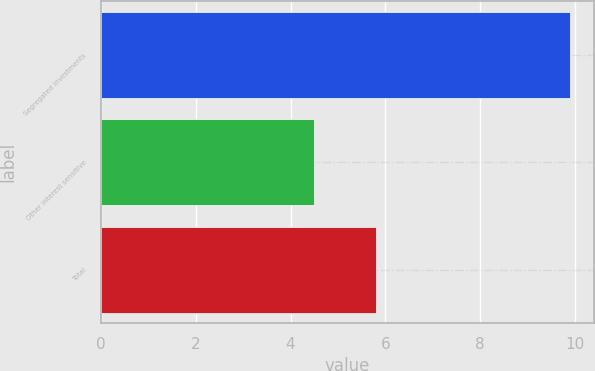Convert chart. <chart><loc_0><loc_0><loc_500><loc_500><bar_chart><fcel>Segregated investments<fcel>Other interest sensitive<fcel>Total<nl><fcel>9.9<fcel>4.5<fcel>5.8<nl></chart> 